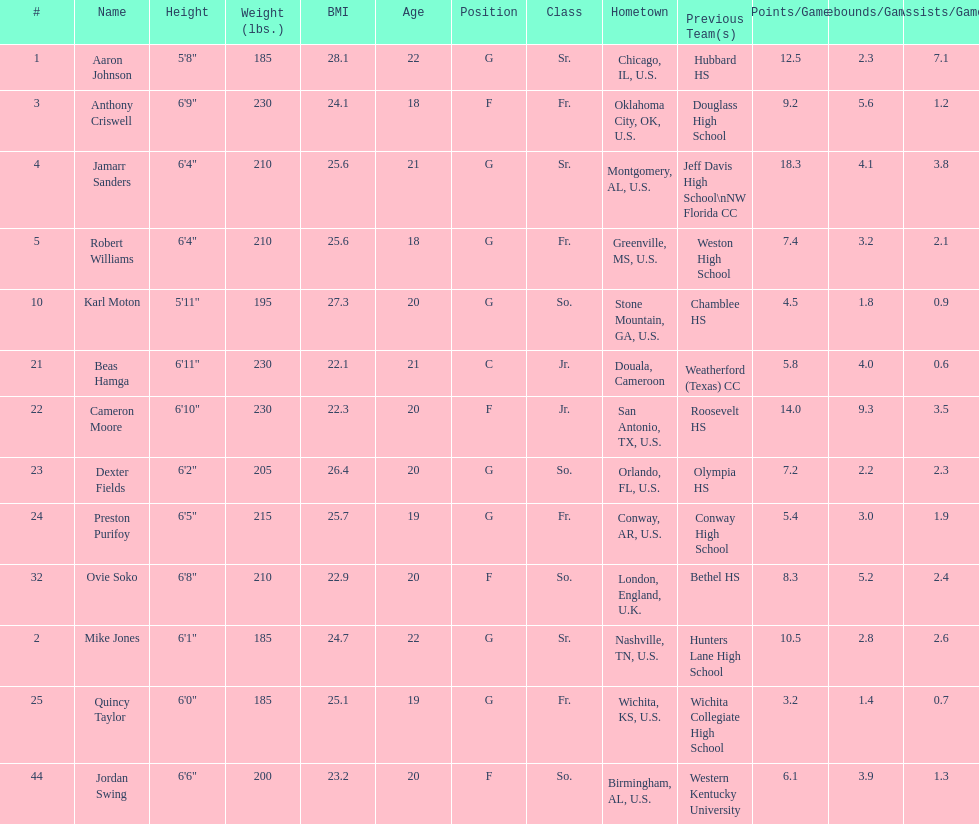What is the number of seniors on the team? 3. 